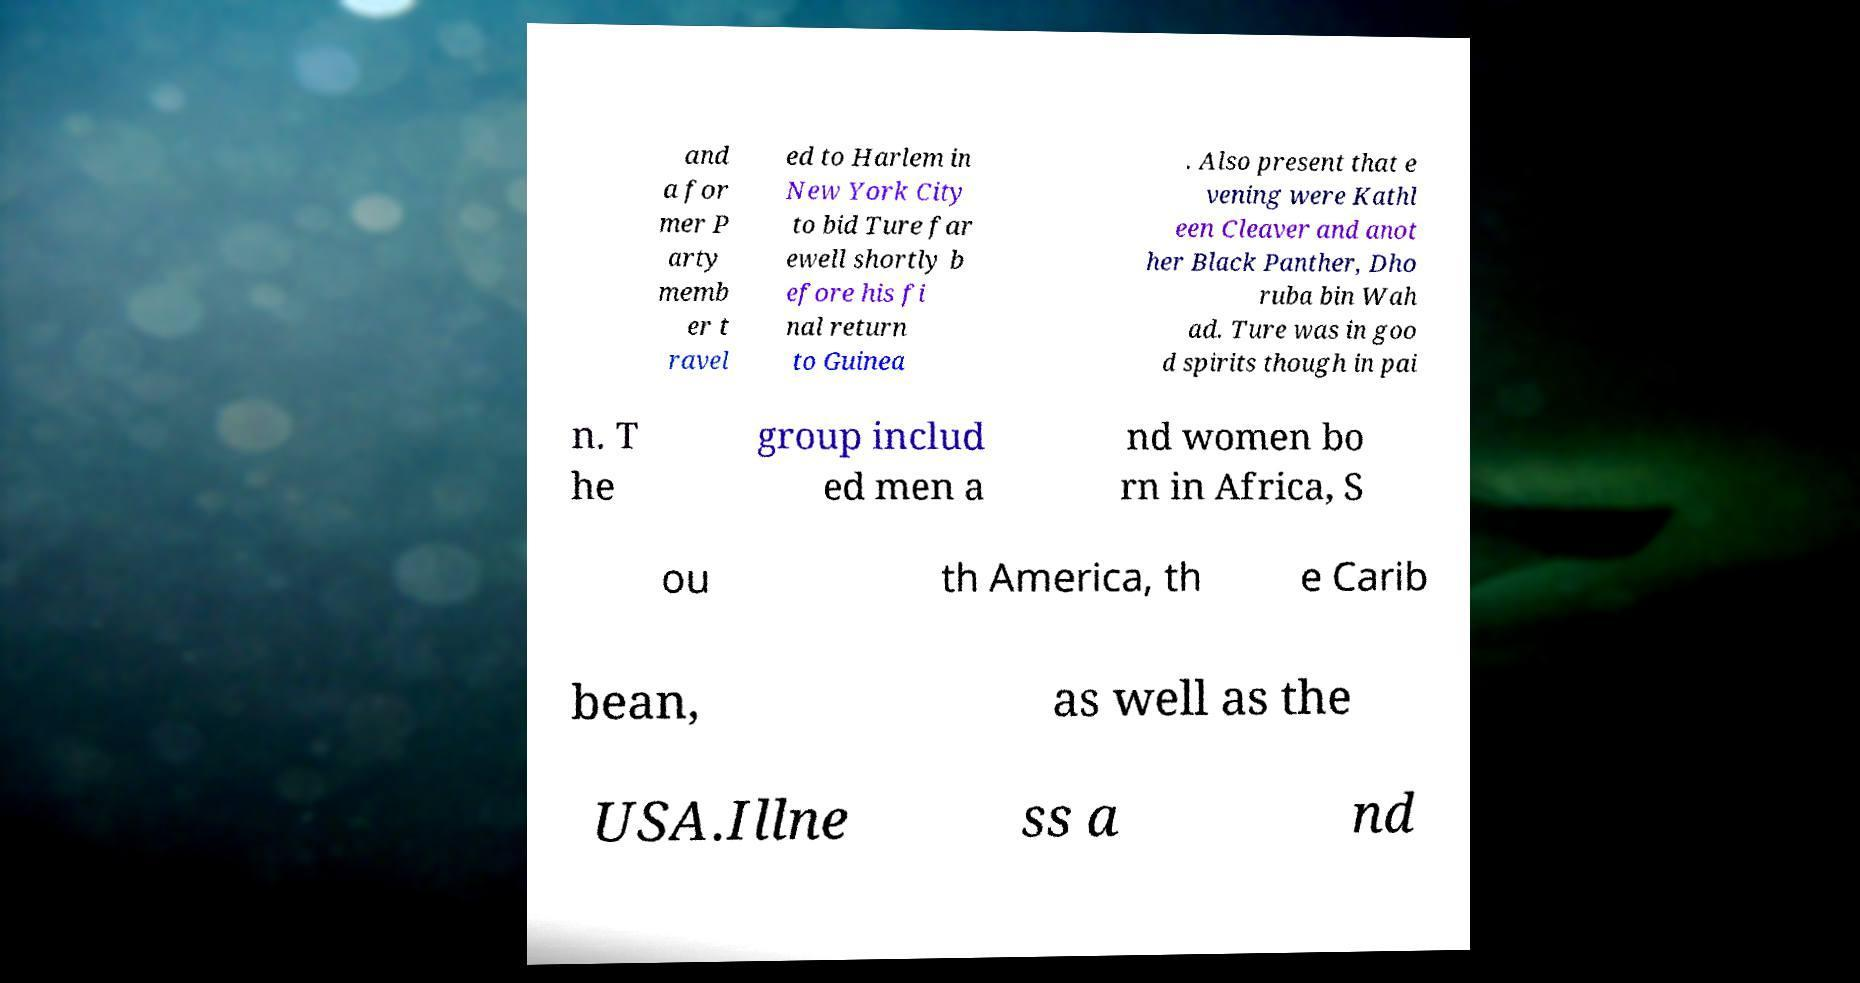Can you accurately transcribe the text from the provided image for me? and a for mer P arty memb er t ravel ed to Harlem in New York City to bid Ture far ewell shortly b efore his fi nal return to Guinea . Also present that e vening were Kathl een Cleaver and anot her Black Panther, Dho ruba bin Wah ad. Ture was in goo d spirits though in pai n. T he group includ ed men a nd women bo rn in Africa, S ou th America, th e Carib bean, as well as the USA.Illne ss a nd 